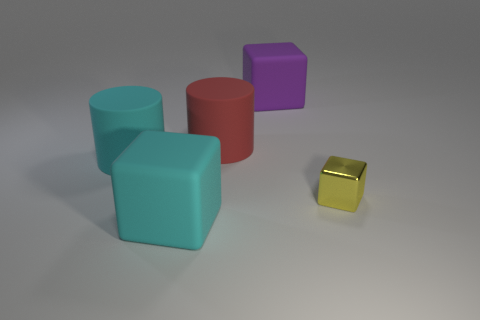Add 4 tiny brown metallic blocks. How many objects exist? 9 Subtract all cylinders. How many objects are left? 3 Add 4 purple objects. How many purple objects exist? 5 Subtract 0 green cylinders. How many objects are left? 5 Subtract all cyan rubber cubes. Subtract all small red cubes. How many objects are left? 4 Add 5 small yellow things. How many small yellow things are left? 6 